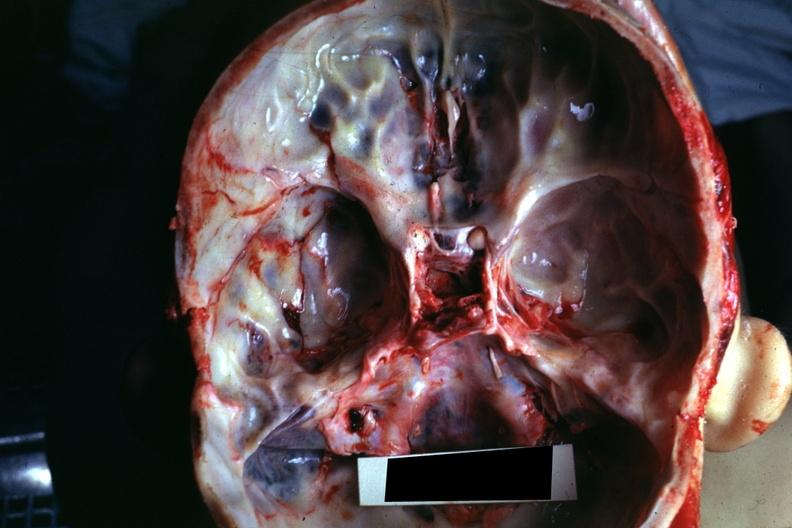what is present?
Answer the question using a single word or phrase. Bone 